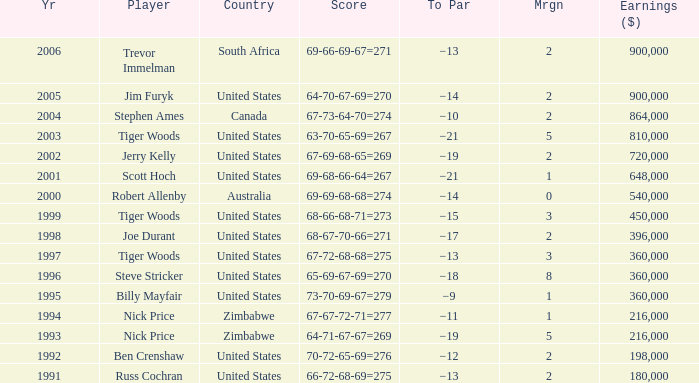Which To Par has Earnings ($) larger than 360,000, and a Year larger than 1998, and a Country of united states, and a Score of 69-68-66-64=267? −21. 